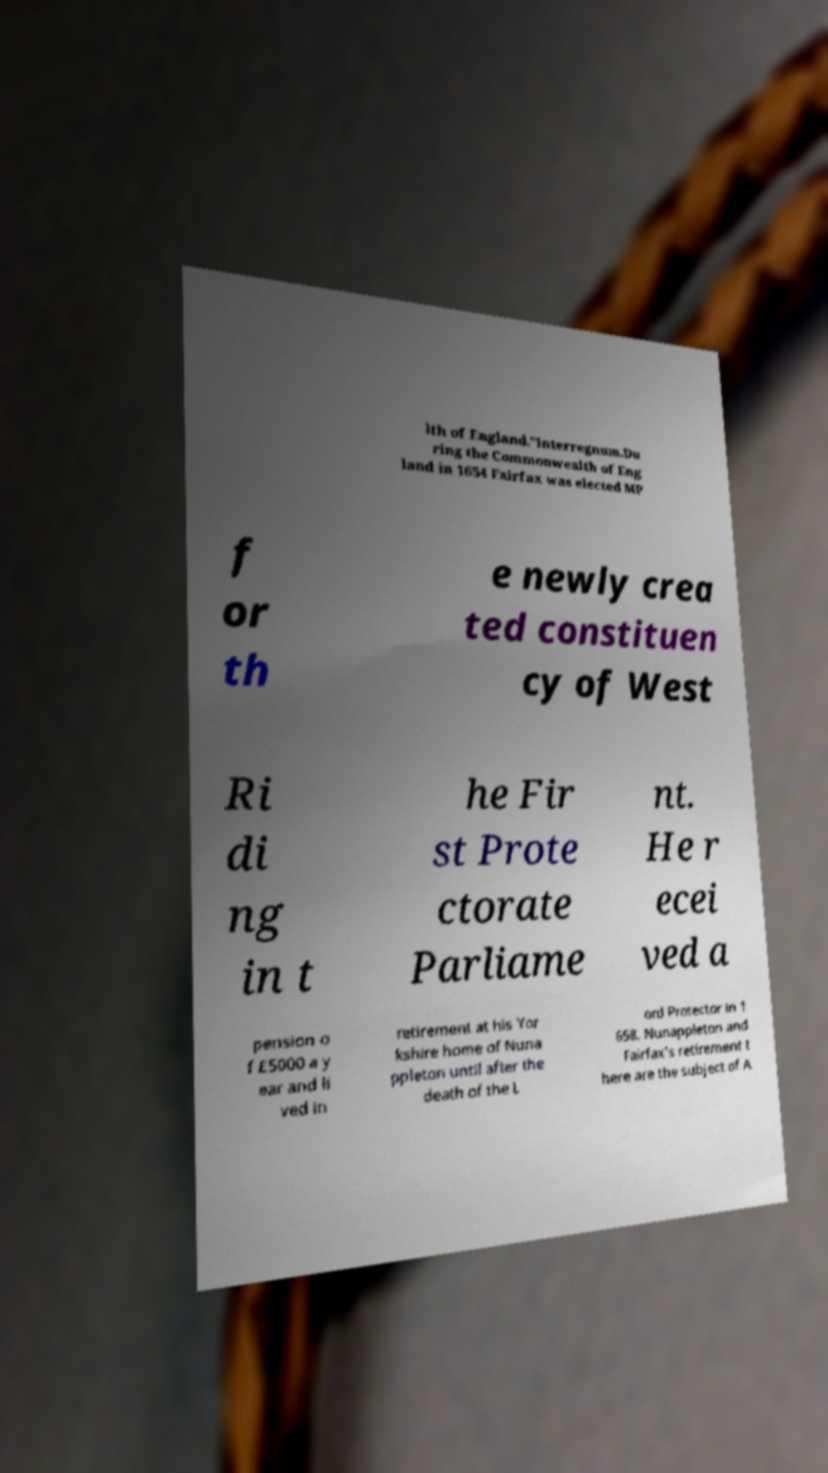I need the written content from this picture converted into text. Can you do that? lth of England."Interregnum.Du ring the Commonwealth of Eng land in 1654 Fairfax was elected MP f or th e newly crea ted constituen cy of West Ri di ng in t he Fir st Prote ctorate Parliame nt. He r ecei ved a pension o f £5000 a y ear and li ved in retirement at his Yor kshire home of Nuna ppleton until after the death of the L ord Protector in 1 658. Nunappleton and Fairfax's retirement t here are the subject of A 